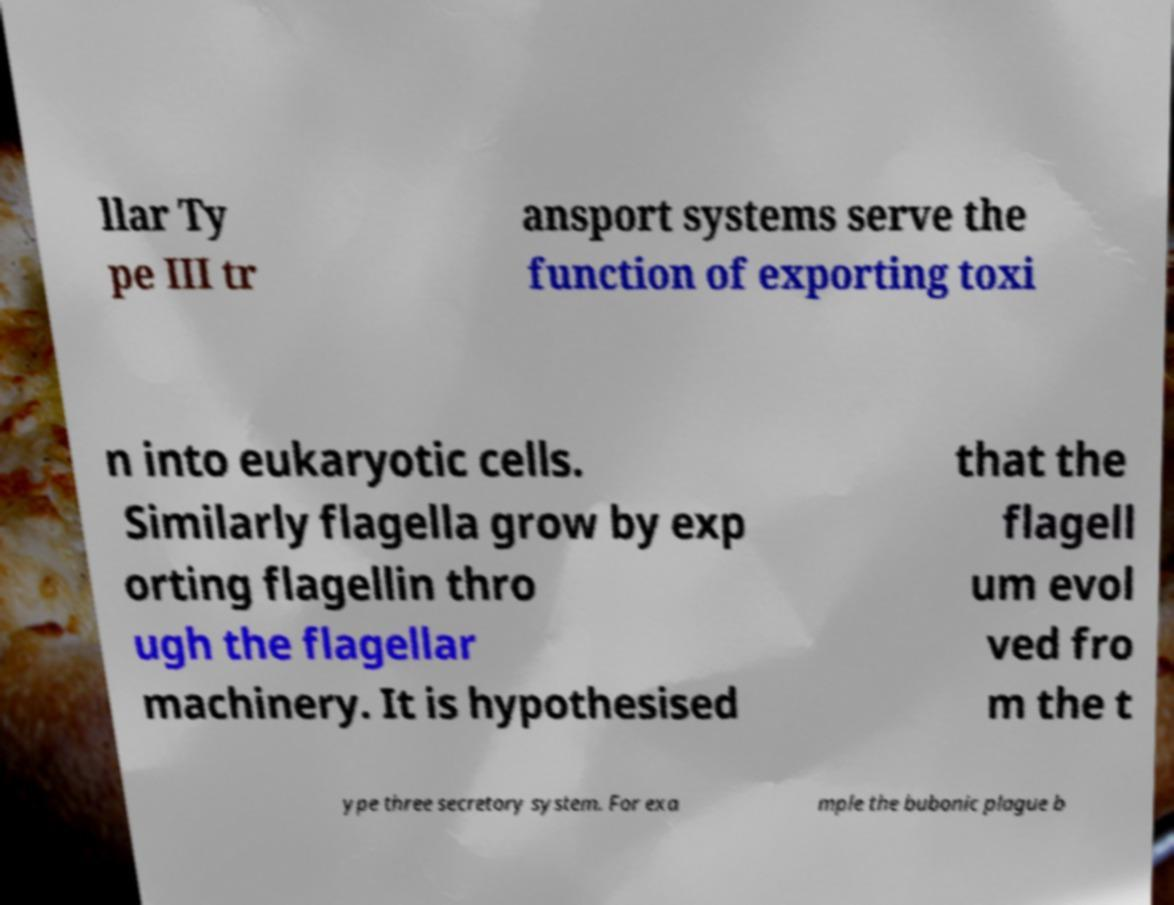For documentation purposes, I need the text within this image transcribed. Could you provide that? llar Ty pe III tr ansport systems serve the function of exporting toxi n into eukaryotic cells. Similarly flagella grow by exp orting flagellin thro ugh the flagellar machinery. It is hypothesised that the flagell um evol ved fro m the t ype three secretory system. For exa mple the bubonic plague b 